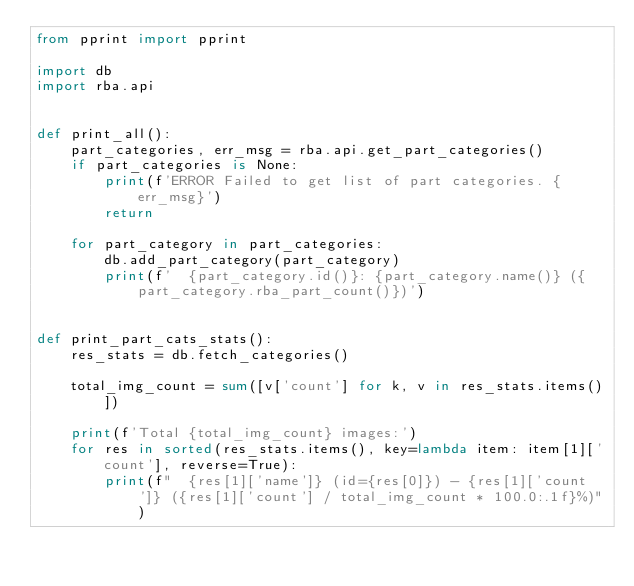Convert code to text. <code><loc_0><loc_0><loc_500><loc_500><_Python_>from pprint import pprint

import db
import rba.api


def print_all():
    part_categories, err_msg = rba.api.get_part_categories()
    if part_categories is None:
        print(f'ERROR Failed to get list of part categories. {err_msg}')
        return

    for part_category in part_categories:
        db.add_part_category(part_category)
        print(f'  {part_category.id()}: {part_category.name()} ({part_category.rba_part_count()})')


def print_part_cats_stats():
    res_stats = db.fetch_categories()

    total_img_count = sum([v['count'] for k, v in res_stats.items()])

    print(f'Total {total_img_count} images:')
    for res in sorted(res_stats.items(), key=lambda item: item[1]['count'], reverse=True):
        print(f"  {res[1]['name']} (id={res[0]}) - {res[1]['count']} ({res[1]['count'] / total_img_count * 100.0:.1f}%)")
</code> 